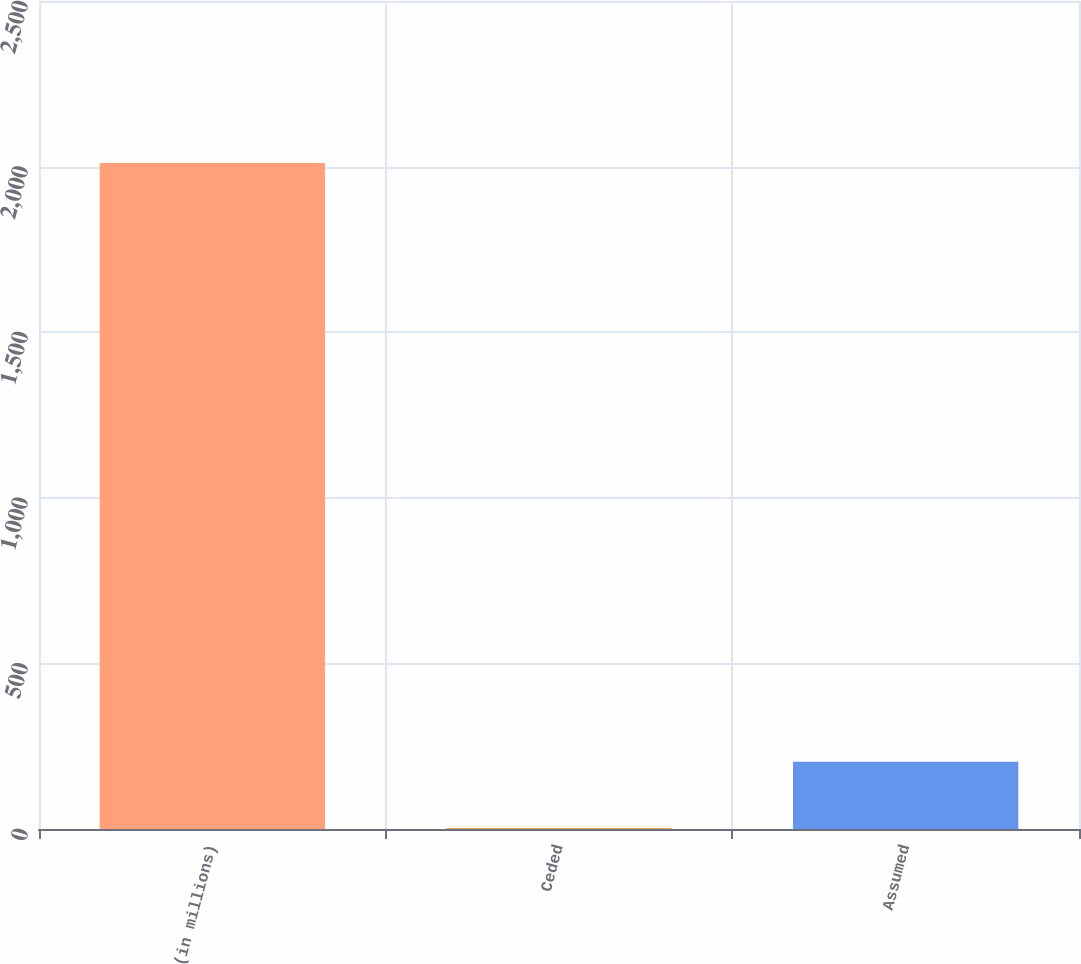Convert chart. <chart><loc_0><loc_0><loc_500><loc_500><bar_chart><fcel>(in millions)<fcel>Ceded<fcel>Assumed<nl><fcel>2011<fcel>2<fcel>202.9<nl></chart> 